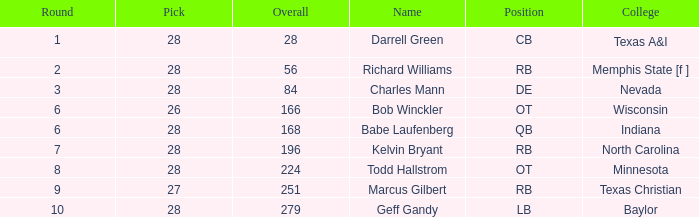What is the highest pick of the player from texas a&i with an overall less than 28? None. 